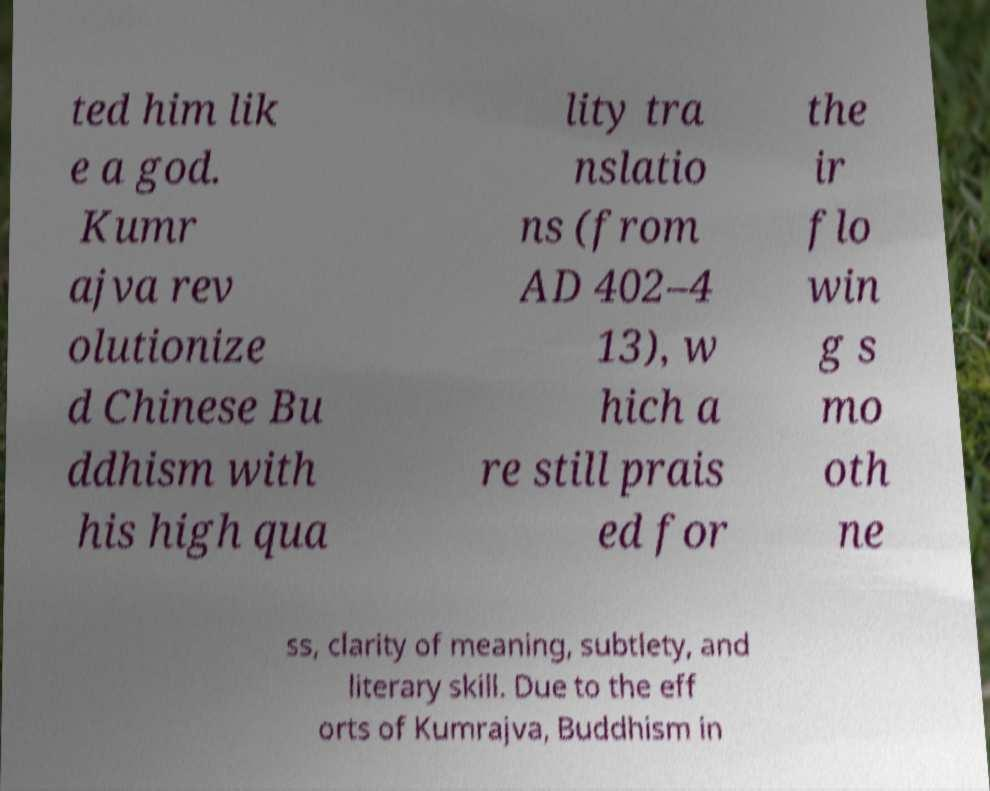What messages or text are displayed in this image? I need them in a readable, typed format. ted him lik e a god. Kumr ajva rev olutionize d Chinese Bu ddhism with his high qua lity tra nslatio ns (from AD 402–4 13), w hich a re still prais ed for the ir flo win g s mo oth ne ss, clarity of meaning, subtlety, and literary skill. Due to the eff orts of Kumrajva, Buddhism in 